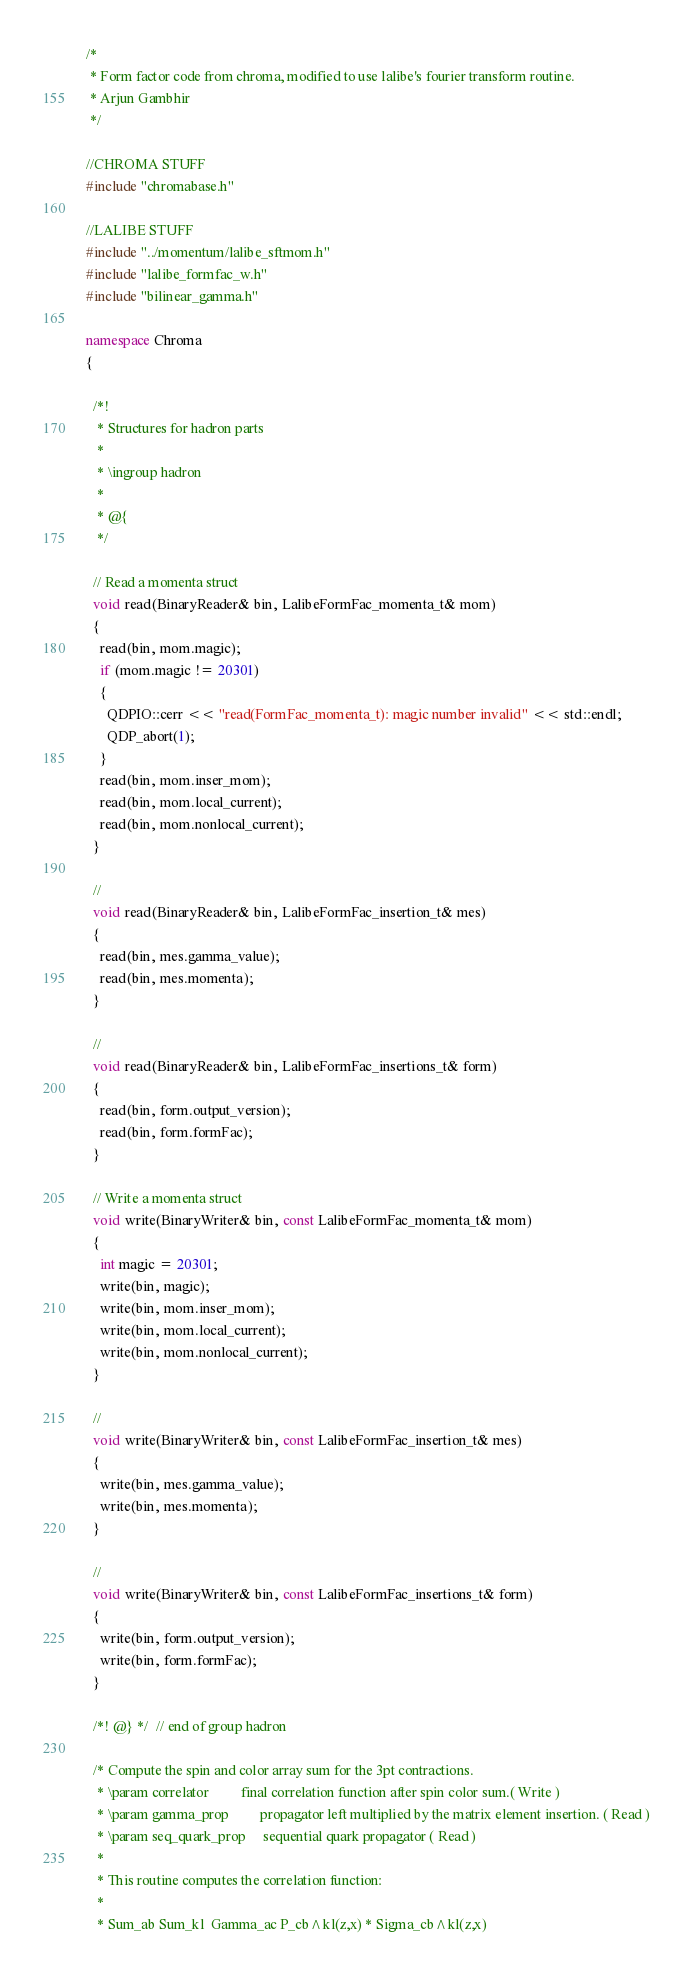<code> <loc_0><loc_0><loc_500><loc_500><_C++_>/*
 * Form factor code from chroma, modified to use lalibe's fourier transform routine.
 * Arjun Gambhir
 */

//CHROMA STUFF
#include "chromabase.h"

//LALIBE STUFF
#include "../momentum/lalibe_sftmom.h"
#include "lalibe_formfac_w.h"
#include "bilinear_gamma.h"

namespace Chroma
{

  /*!
   * Structures for hadron parts
   *
   * \ingroup hadron
   *
   * @{
   */

  // Read a momenta struct
  void read(BinaryReader& bin, LalibeFormFac_momenta_t& mom)
  {
    read(bin, mom.magic);
    if (mom.magic != 20301)
    {
      QDPIO::cerr << "read(FormFac_momenta_t): magic number invalid" << std::endl;
      QDP_abort(1);
    }
    read(bin, mom.inser_mom);
    read(bin, mom.local_current);
    read(bin, mom.nonlocal_current);
  }

  //
  void read(BinaryReader& bin, LalibeFormFac_insertion_t& mes)
  {
    read(bin, mes.gamma_value);
    read(bin, mes.momenta);
  }

  //
  void read(BinaryReader& bin, LalibeFormFac_insertions_t& form)
  {
    read(bin, form.output_version);
    read(bin, form.formFac);
  }

  // Write a momenta struct
  void write(BinaryWriter& bin, const LalibeFormFac_momenta_t& mom)
  {
    int magic = 20301;
    write(bin, magic);
    write(bin, mom.inser_mom);
    write(bin, mom.local_current);
    write(bin, mom.nonlocal_current);
  }

  //
  void write(BinaryWriter& bin, const LalibeFormFac_insertion_t& mes)
  {
    write(bin, mes.gamma_value);
    write(bin, mes.momenta);
  }

  //
  void write(BinaryWriter& bin, const LalibeFormFac_insertions_t& form)
  {
    write(bin, form.output_version);
    write(bin, form.formFac);
  }

  /*! @} */  // end of group hadron

  /* Compute the spin and color array sum for the 3pt contractions.
   * \param correlator         final correlation function after spin color sum.( Write )
   * \param gamma_prop         propagator left multiplied by the matrix element insertion. ( Read )
   * \param seq_quark_prop     sequential quark propagator ( Read )
   *
   * This routine computes the correlation function:
   *
   * Sum_ab Sum_kl  Gamma_ac P_cb^kl(z,x) * Sigma_cb^kl(z,x)</code> 